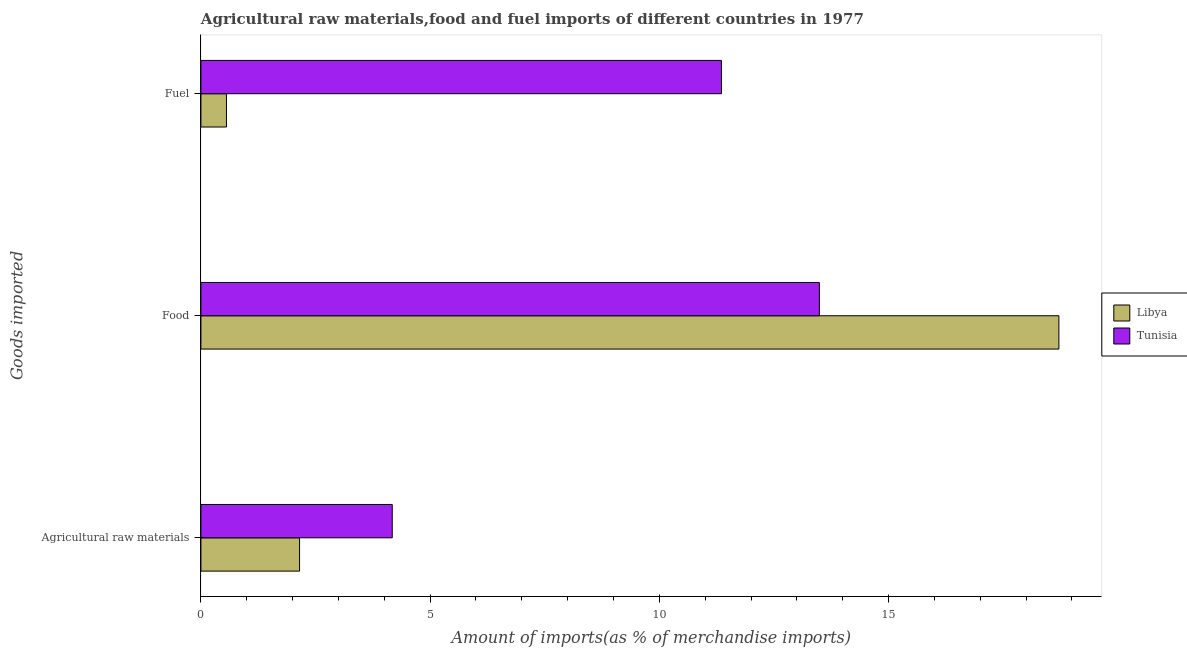How many different coloured bars are there?
Provide a short and direct response. 2. Are the number of bars per tick equal to the number of legend labels?
Your answer should be very brief. Yes. How many bars are there on the 1st tick from the bottom?
Offer a very short reply. 2. What is the label of the 3rd group of bars from the top?
Give a very brief answer. Agricultural raw materials. What is the percentage of food imports in Tunisia?
Provide a short and direct response. 13.49. Across all countries, what is the maximum percentage of raw materials imports?
Offer a very short reply. 4.17. Across all countries, what is the minimum percentage of food imports?
Your response must be concise. 13.49. In which country was the percentage of raw materials imports maximum?
Offer a very short reply. Tunisia. In which country was the percentage of food imports minimum?
Make the answer very short. Tunisia. What is the total percentage of fuel imports in the graph?
Provide a succinct answer. 11.91. What is the difference between the percentage of raw materials imports in Tunisia and that in Libya?
Your answer should be compact. 2.02. What is the difference between the percentage of fuel imports in Tunisia and the percentage of food imports in Libya?
Offer a very short reply. -7.36. What is the average percentage of raw materials imports per country?
Make the answer very short. 3.16. What is the difference between the percentage of food imports and percentage of fuel imports in Tunisia?
Make the answer very short. 2.14. In how many countries, is the percentage of raw materials imports greater than 6 %?
Give a very brief answer. 0. What is the ratio of the percentage of food imports in Tunisia to that in Libya?
Keep it short and to the point. 0.72. What is the difference between the highest and the second highest percentage of food imports?
Make the answer very short. 5.22. What is the difference between the highest and the lowest percentage of raw materials imports?
Your answer should be compact. 2.02. What does the 2nd bar from the top in Agricultural raw materials represents?
Make the answer very short. Libya. What does the 2nd bar from the bottom in Agricultural raw materials represents?
Your answer should be very brief. Tunisia. How many bars are there?
Your response must be concise. 6. How many countries are there in the graph?
Ensure brevity in your answer.  2. What is the difference between two consecutive major ticks on the X-axis?
Your response must be concise. 5. Does the graph contain any zero values?
Offer a very short reply. No. Where does the legend appear in the graph?
Keep it short and to the point. Center right. How are the legend labels stacked?
Your answer should be compact. Vertical. What is the title of the graph?
Ensure brevity in your answer.  Agricultural raw materials,food and fuel imports of different countries in 1977. What is the label or title of the X-axis?
Your response must be concise. Amount of imports(as % of merchandise imports). What is the label or title of the Y-axis?
Your answer should be very brief. Goods imported. What is the Amount of imports(as % of merchandise imports) of Libya in Agricultural raw materials?
Give a very brief answer. 2.15. What is the Amount of imports(as % of merchandise imports) of Tunisia in Agricultural raw materials?
Your response must be concise. 4.17. What is the Amount of imports(as % of merchandise imports) of Libya in Food?
Your answer should be very brief. 18.71. What is the Amount of imports(as % of merchandise imports) of Tunisia in Food?
Offer a terse response. 13.49. What is the Amount of imports(as % of merchandise imports) of Libya in Fuel?
Keep it short and to the point. 0.56. What is the Amount of imports(as % of merchandise imports) in Tunisia in Fuel?
Make the answer very short. 11.35. Across all Goods imported, what is the maximum Amount of imports(as % of merchandise imports) in Libya?
Keep it short and to the point. 18.71. Across all Goods imported, what is the maximum Amount of imports(as % of merchandise imports) in Tunisia?
Your answer should be very brief. 13.49. Across all Goods imported, what is the minimum Amount of imports(as % of merchandise imports) of Libya?
Give a very brief answer. 0.56. Across all Goods imported, what is the minimum Amount of imports(as % of merchandise imports) in Tunisia?
Ensure brevity in your answer.  4.17. What is the total Amount of imports(as % of merchandise imports) in Libya in the graph?
Your answer should be compact. 21.42. What is the total Amount of imports(as % of merchandise imports) of Tunisia in the graph?
Give a very brief answer. 29.02. What is the difference between the Amount of imports(as % of merchandise imports) in Libya in Agricultural raw materials and that in Food?
Keep it short and to the point. -16.56. What is the difference between the Amount of imports(as % of merchandise imports) in Tunisia in Agricultural raw materials and that in Food?
Offer a terse response. -9.32. What is the difference between the Amount of imports(as % of merchandise imports) in Libya in Agricultural raw materials and that in Fuel?
Provide a short and direct response. 1.59. What is the difference between the Amount of imports(as % of merchandise imports) of Tunisia in Agricultural raw materials and that in Fuel?
Give a very brief answer. -7.18. What is the difference between the Amount of imports(as % of merchandise imports) in Libya in Food and that in Fuel?
Ensure brevity in your answer.  18.16. What is the difference between the Amount of imports(as % of merchandise imports) in Tunisia in Food and that in Fuel?
Ensure brevity in your answer.  2.14. What is the difference between the Amount of imports(as % of merchandise imports) of Libya in Agricultural raw materials and the Amount of imports(as % of merchandise imports) of Tunisia in Food?
Make the answer very short. -11.34. What is the difference between the Amount of imports(as % of merchandise imports) in Libya in Agricultural raw materials and the Amount of imports(as % of merchandise imports) in Tunisia in Fuel?
Ensure brevity in your answer.  -9.2. What is the difference between the Amount of imports(as % of merchandise imports) in Libya in Food and the Amount of imports(as % of merchandise imports) in Tunisia in Fuel?
Ensure brevity in your answer.  7.36. What is the average Amount of imports(as % of merchandise imports) in Libya per Goods imported?
Your answer should be very brief. 7.14. What is the average Amount of imports(as % of merchandise imports) of Tunisia per Goods imported?
Your answer should be compact. 9.67. What is the difference between the Amount of imports(as % of merchandise imports) in Libya and Amount of imports(as % of merchandise imports) in Tunisia in Agricultural raw materials?
Your answer should be compact. -2.02. What is the difference between the Amount of imports(as % of merchandise imports) in Libya and Amount of imports(as % of merchandise imports) in Tunisia in Food?
Your response must be concise. 5.22. What is the difference between the Amount of imports(as % of merchandise imports) of Libya and Amount of imports(as % of merchandise imports) of Tunisia in Fuel?
Make the answer very short. -10.8. What is the ratio of the Amount of imports(as % of merchandise imports) in Libya in Agricultural raw materials to that in Food?
Offer a very short reply. 0.12. What is the ratio of the Amount of imports(as % of merchandise imports) in Tunisia in Agricultural raw materials to that in Food?
Your answer should be compact. 0.31. What is the ratio of the Amount of imports(as % of merchandise imports) in Libya in Agricultural raw materials to that in Fuel?
Your response must be concise. 3.86. What is the ratio of the Amount of imports(as % of merchandise imports) in Tunisia in Agricultural raw materials to that in Fuel?
Provide a short and direct response. 0.37. What is the ratio of the Amount of imports(as % of merchandise imports) of Libya in Food to that in Fuel?
Provide a short and direct response. 33.59. What is the ratio of the Amount of imports(as % of merchandise imports) of Tunisia in Food to that in Fuel?
Offer a terse response. 1.19. What is the difference between the highest and the second highest Amount of imports(as % of merchandise imports) in Libya?
Offer a very short reply. 16.56. What is the difference between the highest and the second highest Amount of imports(as % of merchandise imports) in Tunisia?
Ensure brevity in your answer.  2.14. What is the difference between the highest and the lowest Amount of imports(as % of merchandise imports) in Libya?
Give a very brief answer. 18.16. What is the difference between the highest and the lowest Amount of imports(as % of merchandise imports) in Tunisia?
Provide a succinct answer. 9.32. 